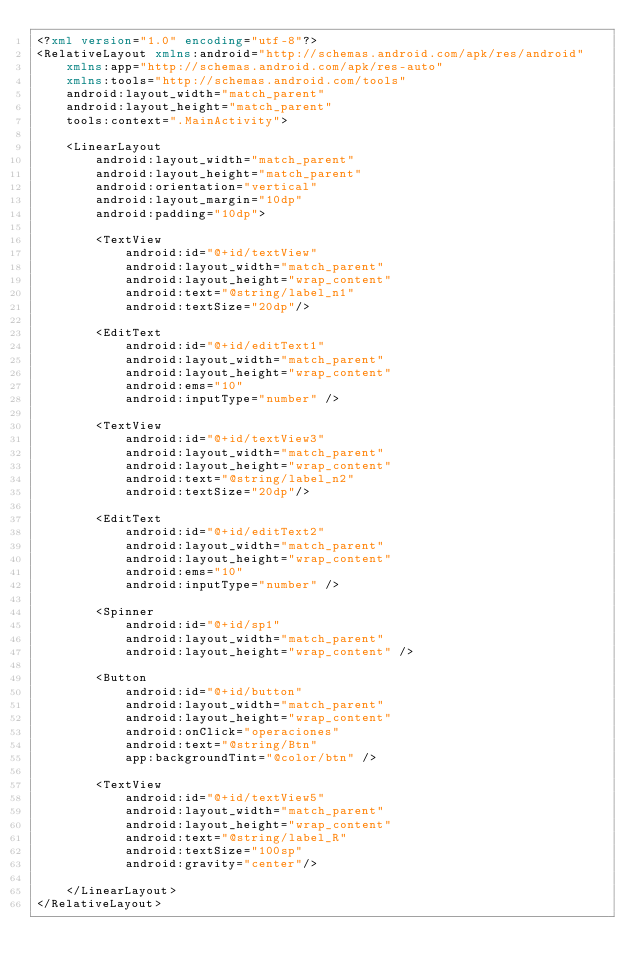Convert code to text. <code><loc_0><loc_0><loc_500><loc_500><_XML_><?xml version="1.0" encoding="utf-8"?>
<RelativeLayout xmlns:android="http://schemas.android.com/apk/res/android"
    xmlns:app="http://schemas.android.com/apk/res-auto"
    xmlns:tools="http://schemas.android.com/tools"
    android:layout_width="match_parent"
    android:layout_height="match_parent"
    tools:context=".MainActivity">

    <LinearLayout
        android:layout_width="match_parent"
        android:layout_height="match_parent"
        android:orientation="vertical"
        android:layout_margin="10dp"
        android:padding="10dp">

        <TextView
            android:id="@+id/textView"
            android:layout_width="match_parent"
            android:layout_height="wrap_content"
            android:text="@string/label_n1"
            android:textSize="20dp"/>

        <EditText
            android:id="@+id/editText1"
            android:layout_width="match_parent"
            android:layout_height="wrap_content"
            android:ems="10"
            android:inputType="number" />

        <TextView
            android:id="@+id/textView3"
            android:layout_width="match_parent"
            android:layout_height="wrap_content"
            android:text="@string/label_n2"
            android:textSize="20dp"/>

        <EditText
            android:id="@+id/editText2"
            android:layout_width="match_parent"
            android:layout_height="wrap_content"
            android:ems="10"
            android:inputType="number" />

        <Spinner
            android:id="@+id/sp1"
            android:layout_width="match_parent"
            android:layout_height="wrap_content" />

        <Button
            android:id="@+id/button"
            android:layout_width="match_parent"
            android:layout_height="wrap_content"
            android:onClick="operaciones"
            android:text="@string/Btn"
            app:backgroundTint="@color/btn" />

        <TextView
            android:id="@+id/textView5"
            android:layout_width="match_parent"
            android:layout_height="wrap_content"
            android:text="@string/label_R"
            android:textSize="100sp"
            android:gravity="center"/>

    </LinearLayout>
</RelativeLayout></code> 